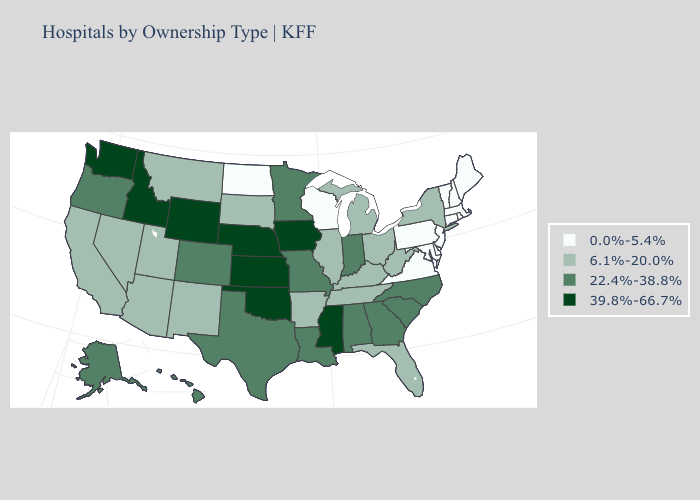Does the first symbol in the legend represent the smallest category?
Concise answer only. Yes. Name the states that have a value in the range 22.4%-38.8%?
Keep it brief. Alabama, Alaska, Colorado, Georgia, Hawaii, Indiana, Louisiana, Minnesota, Missouri, North Carolina, Oregon, South Carolina, Texas. Does Texas have a higher value than Minnesota?
Be succinct. No. What is the highest value in the USA?
Write a very short answer. 39.8%-66.7%. Does Georgia have a lower value than Oklahoma?
Concise answer only. Yes. Which states have the highest value in the USA?
Keep it brief. Idaho, Iowa, Kansas, Mississippi, Nebraska, Oklahoma, Washington, Wyoming. What is the value of Utah?
Concise answer only. 6.1%-20.0%. Name the states that have a value in the range 22.4%-38.8%?
Give a very brief answer. Alabama, Alaska, Colorado, Georgia, Hawaii, Indiana, Louisiana, Minnesota, Missouri, North Carolina, Oregon, South Carolina, Texas. What is the lowest value in the USA?
Answer briefly. 0.0%-5.4%. Among the states that border North Carolina , does Virginia have the lowest value?
Keep it brief. Yes. Does South Dakota have a lower value than Illinois?
Short answer required. No. Does Louisiana have the same value as Utah?
Answer briefly. No. Among the states that border Arizona , which have the lowest value?
Write a very short answer. California, Nevada, New Mexico, Utah. What is the lowest value in the Northeast?
Short answer required. 0.0%-5.4%. Name the states that have a value in the range 6.1%-20.0%?
Keep it brief. Arizona, Arkansas, California, Florida, Illinois, Kentucky, Michigan, Montana, Nevada, New Mexico, New York, Ohio, South Dakota, Tennessee, Utah, West Virginia. 